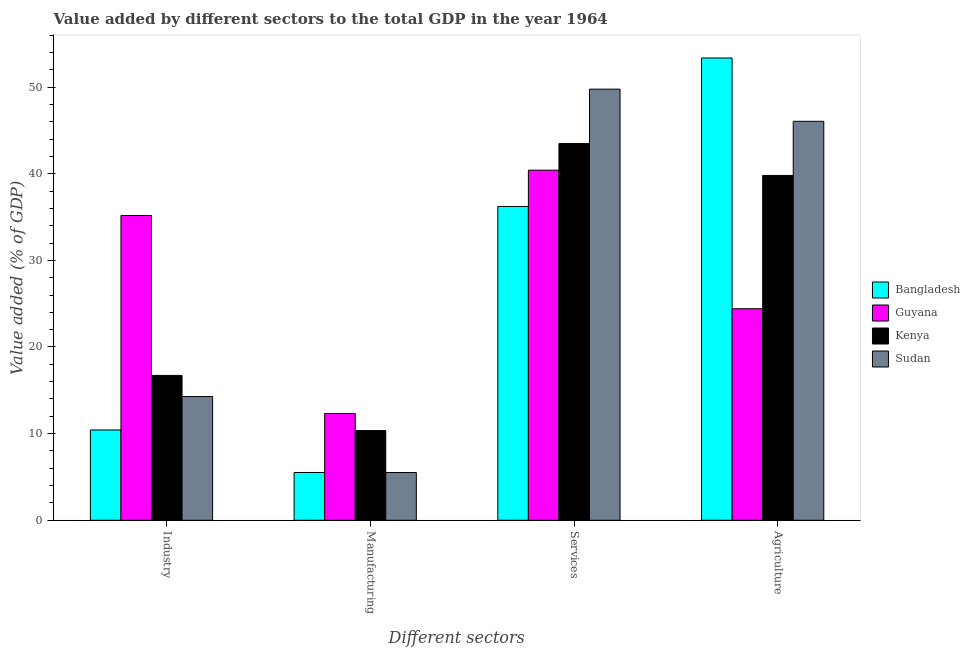How many different coloured bars are there?
Ensure brevity in your answer.  4. How many groups of bars are there?
Provide a short and direct response. 4. Are the number of bars per tick equal to the number of legend labels?
Keep it short and to the point. Yes. How many bars are there on the 4th tick from the left?
Provide a short and direct response. 4. What is the label of the 1st group of bars from the left?
Offer a very short reply. Industry. What is the value added by manufacturing sector in Sudan?
Ensure brevity in your answer.  5.51. Across all countries, what is the maximum value added by agricultural sector?
Your answer should be very brief. 53.36. Across all countries, what is the minimum value added by services sector?
Provide a succinct answer. 36.22. In which country was the value added by industrial sector maximum?
Offer a very short reply. Guyana. In which country was the value added by services sector minimum?
Your answer should be compact. Bangladesh. What is the total value added by manufacturing sector in the graph?
Offer a very short reply. 33.7. What is the difference between the value added by agricultural sector in Guyana and that in Sudan?
Provide a short and direct response. -21.63. What is the difference between the value added by manufacturing sector in Bangladesh and the value added by industrial sector in Guyana?
Offer a very short reply. -29.66. What is the average value added by services sector per country?
Your answer should be compact. 42.47. What is the difference between the value added by manufacturing sector and value added by services sector in Bangladesh?
Your answer should be very brief. -30.71. In how many countries, is the value added by industrial sector greater than 54 %?
Provide a short and direct response. 0. What is the ratio of the value added by industrial sector in Kenya to that in Bangladesh?
Make the answer very short. 1.6. Is the value added by services sector in Guyana less than that in Bangladesh?
Give a very brief answer. No. Is the difference between the value added by services sector in Sudan and Guyana greater than the difference between the value added by industrial sector in Sudan and Guyana?
Make the answer very short. Yes. What is the difference between the highest and the second highest value added by agricultural sector?
Provide a succinct answer. 7.31. What is the difference between the highest and the lowest value added by agricultural sector?
Offer a very short reply. 28.94. In how many countries, is the value added by manufacturing sector greater than the average value added by manufacturing sector taken over all countries?
Your answer should be compact. 2. Is it the case that in every country, the sum of the value added by industrial sector and value added by services sector is greater than the sum of value added by manufacturing sector and value added by agricultural sector?
Make the answer very short. No. What does the 3rd bar from the left in Services represents?
Keep it short and to the point. Kenya. What does the 2nd bar from the right in Manufacturing represents?
Your response must be concise. Kenya. Is it the case that in every country, the sum of the value added by industrial sector and value added by manufacturing sector is greater than the value added by services sector?
Offer a terse response. No. How many bars are there?
Provide a short and direct response. 16. Are all the bars in the graph horizontal?
Provide a short and direct response. No. How many countries are there in the graph?
Give a very brief answer. 4. What is the difference between two consecutive major ticks on the Y-axis?
Provide a short and direct response. 10. Are the values on the major ticks of Y-axis written in scientific E-notation?
Ensure brevity in your answer.  No. Does the graph contain any zero values?
Your answer should be very brief. No. Where does the legend appear in the graph?
Make the answer very short. Center right. How many legend labels are there?
Offer a very short reply. 4. What is the title of the graph?
Provide a short and direct response. Value added by different sectors to the total GDP in the year 1964. Does "Malta" appear as one of the legend labels in the graph?
Offer a very short reply. No. What is the label or title of the X-axis?
Offer a terse response. Different sectors. What is the label or title of the Y-axis?
Offer a terse response. Value added (% of GDP). What is the Value added (% of GDP) of Bangladesh in Industry?
Your answer should be very brief. 10.42. What is the Value added (% of GDP) of Guyana in Industry?
Provide a succinct answer. 35.18. What is the Value added (% of GDP) in Kenya in Industry?
Offer a terse response. 16.72. What is the Value added (% of GDP) in Sudan in Industry?
Your answer should be compact. 14.28. What is the Value added (% of GDP) in Bangladesh in Manufacturing?
Provide a short and direct response. 5.51. What is the Value added (% of GDP) in Guyana in Manufacturing?
Your answer should be compact. 12.33. What is the Value added (% of GDP) of Kenya in Manufacturing?
Your answer should be very brief. 10.35. What is the Value added (% of GDP) of Sudan in Manufacturing?
Your response must be concise. 5.51. What is the Value added (% of GDP) of Bangladesh in Services?
Ensure brevity in your answer.  36.22. What is the Value added (% of GDP) of Guyana in Services?
Provide a short and direct response. 40.41. What is the Value added (% of GDP) in Kenya in Services?
Make the answer very short. 43.48. What is the Value added (% of GDP) of Sudan in Services?
Provide a succinct answer. 49.76. What is the Value added (% of GDP) in Bangladesh in Agriculture?
Keep it short and to the point. 53.36. What is the Value added (% of GDP) in Guyana in Agriculture?
Give a very brief answer. 24.42. What is the Value added (% of GDP) in Kenya in Agriculture?
Your response must be concise. 39.8. What is the Value added (% of GDP) of Sudan in Agriculture?
Make the answer very short. 46.05. Across all Different sectors, what is the maximum Value added (% of GDP) in Bangladesh?
Provide a short and direct response. 53.36. Across all Different sectors, what is the maximum Value added (% of GDP) of Guyana?
Give a very brief answer. 40.41. Across all Different sectors, what is the maximum Value added (% of GDP) of Kenya?
Provide a short and direct response. 43.48. Across all Different sectors, what is the maximum Value added (% of GDP) in Sudan?
Ensure brevity in your answer.  49.76. Across all Different sectors, what is the minimum Value added (% of GDP) in Bangladesh?
Make the answer very short. 5.51. Across all Different sectors, what is the minimum Value added (% of GDP) of Guyana?
Your response must be concise. 12.33. Across all Different sectors, what is the minimum Value added (% of GDP) of Kenya?
Your answer should be very brief. 10.35. Across all Different sectors, what is the minimum Value added (% of GDP) in Sudan?
Give a very brief answer. 5.51. What is the total Value added (% of GDP) in Bangladesh in the graph?
Your answer should be very brief. 105.51. What is the total Value added (% of GDP) of Guyana in the graph?
Give a very brief answer. 112.33. What is the total Value added (% of GDP) in Kenya in the graph?
Provide a succinct answer. 110.35. What is the total Value added (% of GDP) in Sudan in the graph?
Make the answer very short. 115.6. What is the difference between the Value added (% of GDP) of Bangladesh in Industry and that in Manufacturing?
Ensure brevity in your answer.  4.91. What is the difference between the Value added (% of GDP) of Guyana in Industry and that in Manufacturing?
Provide a succinct answer. 22.85. What is the difference between the Value added (% of GDP) of Kenya in Industry and that in Manufacturing?
Provide a short and direct response. 6.37. What is the difference between the Value added (% of GDP) of Sudan in Industry and that in Manufacturing?
Provide a succinct answer. 8.77. What is the difference between the Value added (% of GDP) in Bangladesh in Industry and that in Services?
Provide a short and direct response. -25.8. What is the difference between the Value added (% of GDP) of Guyana in Industry and that in Services?
Provide a short and direct response. -5.23. What is the difference between the Value added (% of GDP) of Kenya in Industry and that in Services?
Offer a very short reply. -26.76. What is the difference between the Value added (% of GDP) of Sudan in Industry and that in Services?
Provide a succinct answer. -35.48. What is the difference between the Value added (% of GDP) in Bangladesh in Industry and that in Agriculture?
Keep it short and to the point. -42.93. What is the difference between the Value added (% of GDP) of Guyana in Industry and that in Agriculture?
Ensure brevity in your answer.  10.76. What is the difference between the Value added (% of GDP) of Kenya in Industry and that in Agriculture?
Provide a succinct answer. -23.08. What is the difference between the Value added (% of GDP) in Sudan in Industry and that in Agriculture?
Offer a very short reply. -31.77. What is the difference between the Value added (% of GDP) in Bangladesh in Manufacturing and that in Services?
Your answer should be very brief. -30.71. What is the difference between the Value added (% of GDP) in Guyana in Manufacturing and that in Services?
Offer a terse response. -28.08. What is the difference between the Value added (% of GDP) of Kenya in Manufacturing and that in Services?
Your response must be concise. -33.13. What is the difference between the Value added (% of GDP) of Sudan in Manufacturing and that in Services?
Your answer should be very brief. -44.25. What is the difference between the Value added (% of GDP) of Bangladesh in Manufacturing and that in Agriculture?
Offer a very short reply. -47.84. What is the difference between the Value added (% of GDP) in Guyana in Manufacturing and that in Agriculture?
Give a very brief answer. -12.09. What is the difference between the Value added (% of GDP) in Kenya in Manufacturing and that in Agriculture?
Your answer should be very brief. -29.45. What is the difference between the Value added (% of GDP) of Sudan in Manufacturing and that in Agriculture?
Give a very brief answer. -40.54. What is the difference between the Value added (% of GDP) of Bangladesh in Services and that in Agriculture?
Offer a very short reply. -17.14. What is the difference between the Value added (% of GDP) of Guyana in Services and that in Agriculture?
Your answer should be very brief. 15.99. What is the difference between the Value added (% of GDP) in Kenya in Services and that in Agriculture?
Make the answer very short. 3.68. What is the difference between the Value added (% of GDP) in Sudan in Services and that in Agriculture?
Provide a succinct answer. 3.71. What is the difference between the Value added (% of GDP) in Bangladesh in Industry and the Value added (% of GDP) in Guyana in Manufacturing?
Offer a terse response. -1.9. What is the difference between the Value added (% of GDP) in Bangladesh in Industry and the Value added (% of GDP) in Kenya in Manufacturing?
Your answer should be very brief. 0.07. What is the difference between the Value added (% of GDP) of Bangladesh in Industry and the Value added (% of GDP) of Sudan in Manufacturing?
Offer a terse response. 4.91. What is the difference between the Value added (% of GDP) of Guyana in Industry and the Value added (% of GDP) of Kenya in Manufacturing?
Ensure brevity in your answer.  24.83. What is the difference between the Value added (% of GDP) of Guyana in Industry and the Value added (% of GDP) of Sudan in Manufacturing?
Provide a succinct answer. 29.67. What is the difference between the Value added (% of GDP) in Kenya in Industry and the Value added (% of GDP) in Sudan in Manufacturing?
Offer a terse response. 11.21. What is the difference between the Value added (% of GDP) in Bangladesh in Industry and the Value added (% of GDP) in Guyana in Services?
Provide a succinct answer. -29.98. What is the difference between the Value added (% of GDP) in Bangladesh in Industry and the Value added (% of GDP) in Kenya in Services?
Provide a succinct answer. -33.06. What is the difference between the Value added (% of GDP) in Bangladesh in Industry and the Value added (% of GDP) in Sudan in Services?
Keep it short and to the point. -39.34. What is the difference between the Value added (% of GDP) in Guyana in Industry and the Value added (% of GDP) in Kenya in Services?
Keep it short and to the point. -8.3. What is the difference between the Value added (% of GDP) in Guyana in Industry and the Value added (% of GDP) in Sudan in Services?
Ensure brevity in your answer.  -14.58. What is the difference between the Value added (% of GDP) in Kenya in Industry and the Value added (% of GDP) in Sudan in Services?
Keep it short and to the point. -33.04. What is the difference between the Value added (% of GDP) in Bangladesh in Industry and the Value added (% of GDP) in Guyana in Agriculture?
Provide a succinct answer. -13.99. What is the difference between the Value added (% of GDP) of Bangladesh in Industry and the Value added (% of GDP) of Kenya in Agriculture?
Your response must be concise. -29.38. What is the difference between the Value added (% of GDP) of Bangladesh in Industry and the Value added (% of GDP) of Sudan in Agriculture?
Your answer should be very brief. -35.63. What is the difference between the Value added (% of GDP) of Guyana in Industry and the Value added (% of GDP) of Kenya in Agriculture?
Offer a very short reply. -4.62. What is the difference between the Value added (% of GDP) of Guyana in Industry and the Value added (% of GDP) of Sudan in Agriculture?
Your answer should be very brief. -10.87. What is the difference between the Value added (% of GDP) of Kenya in Industry and the Value added (% of GDP) of Sudan in Agriculture?
Offer a very short reply. -29.33. What is the difference between the Value added (% of GDP) of Bangladesh in Manufacturing and the Value added (% of GDP) of Guyana in Services?
Ensure brevity in your answer.  -34.89. What is the difference between the Value added (% of GDP) in Bangladesh in Manufacturing and the Value added (% of GDP) in Kenya in Services?
Offer a terse response. -37.97. What is the difference between the Value added (% of GDP) of Bangladesh in Manufacturing and the Value added (% of GDP) of Sudan in Services?
Your answer should be compact. -44.25. What is the difference between the Value added (% of GDP) of Guyana in Manufacturing and the Value added (% of GDP) of Kenya in Services?
Provide a short and direct response. -31.16. What is the difference between the Value added (% of GDP) in Guyana in Manufacturing and the Value added (% of GDP) in Sudan in Services?
Provide a short and direct response. -37.44. What is the difference between the Value added (% of GDP) in Kenya in Manufacturing and the Value added (% of GDP) in Sudan in Services?
Keep it short and to the point. -39.41. What is the difference between the Value added (% of GDP) of Bangladesh in Manufacturing and the Value added (% of GDP) of Guyana in Agriculture?
Your answer should be compact. -18.9. What is the difference between the Value added (% of GDP) of Bangladesh in Manufacturing and the Value added (% of GDP) of Kenya in Agriculture?
Your response must be concise. -34.29. What is the difference between the Value added (% of GDP) of Bangladesh in Manufacturing and the Value added (% of GDP) of Sudan in Agriculture?
Provide a succinct answer. -40.53. What is the difference between the Value added (% of GDP) in Guyana in Manufacturing and the Value added (% of GDP) in Kenya in Agriculture?
Your response must be concise. -27.48. What is the difference between the Value added (% of GDP) in Guyana in Manufacturing and the Value added (% of GDP) in Sudan in Agriculture?
Your answer should be compact. -33.72. What is the difference between the Value added (% of GDP) of Kenya in Manufacturing and the Value added (% of GDP) of Sudan in Agriculture?
Ensure brevity in your answer.  -35.7. What is the difference between the Value added (% of GDP) in Bangladesh in Services and the Value added (% of GDP) in Guyana in Agriculture?
Provide a short and direct response. 11.8. What is the difference between the Value added (% of GDP) of Bangladesh in Services and the Value added (% of GDP) of Kenya in Agriculture?
Provide a succinct answer. -3.58. What is the difference between the Value added (% of GDP) of Bangladesh in Services and the Value added (% of GDP) of Sudan in Agriculture?
Ensure brevity in your answer.  -9.83. What is the difference between the Value added (% of GDP) in Guyana in Services and the Value added (% of GDP) in Kenya in Agriculture?
Keep it short and to the point. 0.61. What is the difference between the Value added (% of GDP) of Guyana in Services and the Value added (% of GDP) of Sudan in Agriculture?
Your response must be concise. -5.64. What is the difference between the Value added (% of GDP) of Kenya in Services and the Value added (% of GDP) of Sudan in Agriculture?
Make the answer very short. -2.57. What is the average Value added (% of GDP) of Bangladesh per Different sectors?
Offer a very short reply. 26.38. What is the average Value added (% of GDP) of Guyana per Different sectors?
Offer a very short reply. 28.08. What is the average Value added (% of GDP) in Kenya per Different sectors?
Keep it short and to the point. 27.59. What is the average Value added (% of GDP) in Sudan per Different sectors?
Give a very brief answer. 28.9. What is the difference between the Value added (% of GDP) of Bangladesh and Value added (% of GDP) of Guyana in Industry?
Provide a succinct answer. -24.75. What is the difference between the Value added (% of GDP) in Bangladesh and Value added (% of GDP) in Kenya in Industry?
Give a very brief answer. -6.3. What is the difference between the Value added (% of GDP) in Bangladesh and Value added (% of GDP) in Sudan in Industry?
Offer a terse response. -3.86. What is the difference between the Value added (% of GDP) in Guyana and Value added (% of GDP) in Kenya in Industry?
Provide a succinct answer. 18.46. What is the difference between the Value added (% of GDP) in Guyana and Value added (% of GDP) in Sudan in Industry?
Provide a succinct answer. 20.9. What is the difference between the Value added (% of GDP) in Kenya and Value added (% of GDP) in Sudan in Industry?
Offer a terse response. 2.44. What is the difference between the Value added (% of GDP) of Bangladesh and Value added (% of GDP) of Guyana in Manufacturing?
Your answer should be compact. -6.81. What is the difference between the Value added (% of GDP) in Bangladesh and Value added (% of GDP) in Kenya in Manufacturing?
Provide a succinct answer. -4.84. What is the difference between the Value added (% of GDP) in Bangladesh and Value added (% of GDP) in Sudan in Manufacturing?
Your response must be concise. 0. What is the difference between the Value added (% of GDP) of Guyana and Value added (% of GDP) of Kenya in Manufacturing?
Provide a short and direct response. 1.97. What is the difference between the Value added (% of GDP) in Guyana and Value added (% of GDP) in Sudan in Manufacturing?
Your response must be concise. 6.81. What is the difference between the Value added (% of GDP) in Kenya and Value added (% of GDP) in Sudan in Manufacturing?
Provide a short and direct response. 4.84. What is the difference between the Value added (% of GDP) of Bangladesh and Value added (% of GDP) of Guyana in Services?
Your response must be concise. -4.19. What is the difference between the Value added (% of GDP) of Bangladesh and Value added (% of GDP) of Kenya in Services?
Give a very brief answer. -7.26. What is the difference between the Value added (% of GDP) in Bangladesh and Value added (% of GDP) in Sudan in Services?
Make the answer very short. -13.54. What is the difference between the Value added (% of GDP) in Guyana and Value added (% of GDP) in Kenya in Services?
Your answer should be compact. -3.07. What is the difference between the Value added (% of GDP) of Guyana and Value added (% of GDP) of Sudan in Services?
Your answer should be compact. -9.35. What is the difference between the Value added (% of GDP) in Kenya and Value added (% of GDP) in Sudan in Services?
Your answer should be compact. -6.28. What is the difference between the Value added (% of GDP) of Bangladesh and Value added (% of GDP) of Guyana in Agriculture?
Provide a short and direct response. 28.94. What is the difference between the Value added (% of GDP) of Bangladesh and Value added (% of GDP) of Kenya in Agriculture?
Give a very brief answer. 13.56. What is the difference between the Value added (% of GDP) of Bangladesh and Value added (% of GDP) of Sudan in Agriculture?
Your answer should be very brief. 7.31. What is the difference between the Value added (% of GDP) of Guyana and Value added (% of GDP) of Kenya in Agriculture?
Your answer should be compact. -15.38. What is the difference between the Value added (% of GDP) of Guyana and Value added (% of GDP) of Sudan in Agriculture?
Provide a short and direct response. -21.63. What is the difference between the Value added (% of GDP) in Kenya and Value added (% of GDP) in Sudan in Agriculture?
Provide a succinct answer. -6.25. What is the ratio of the Value added (% of GDP) of Bangladesh in Industry to that in Manufacturing?
Offer a terse response. 1.89. What is the ratio of the Value added (% of GDP) of Guyana in Industry to that in Manufacturing?
Offer a terse response. 2.85. What is the ratio of the Value added (% of GDP) in Kenya in Industry to that in Manufacturing?
Your response must be concise. 1.62. What is the ratio of the Value added (% of GDP) in Sudan in Industry to that in Manufacturing?
Make the answer very short. 2.59. What is the ratio of the Value added (% of GDP) of Bangladesh in Industry to that in Services?
Offer a very short reply. 0.29. What is the ratio of the Value added (% of GDP) of Guyana in Industry to that in Services?
Provide a succinct answer. 0.87. What is the ratio of the Value added (% of GDP) in Kenya in Industry to that in Services?
Your answer should be very brief. 0.38. What is the ratio of the Value added (% of GDP) in Sudan in Industry to that in Services?
Ensure brevity in your answer.  0.29. What is the ratio of the Value added (% of GDP) in Bangladesh in Industry to that in Agriculture?
Offer a very short reply. 0.2. What is the ratio of the Value added (% of GDP) in Guyana in Industry to that in Agriculture?
Ensure brevity in your answer.  1.44. What is the ratio of the Value added (% of GDP) in Kenya in Industry to that in Agriculture?
Your answer should be very brief. 0.42. What is the ratio of the Value added (% of GDP) in Sudan in Industry to that in Agriculture?
Keep it short and to the point. 0.31. What is the ratio of the Value added (% of GDP) in Bangladesh in Manufacturing to that in Services?
Ensure brevity in your answer.  0.15. What is the ratio of the Value added (% of GDP) in Guyana in Manufacturing to that in Services?
Give a very brief answer. 0.3. What is the ratio of the Value added (% of GDP) of Kenya in Manufacturing to that in Services?
Your answer should be compact. 0.24. What is the ratio of the Value added (% of GDP) of Sudan in Manufacturing to that in Services?
Provide a short and direct response. 0.11. What is the ratio of the Value added (% of GDP) of Bangladesh in Manufacturing to that in Agriculture?
Your answer should be compact. 0.1. What is the ratio of the Value added (% of GDP) of Guyana in Manufacturing to that in Agriculture?
Make the answer very short. 0.5. What is the ratio of the Value added (% of GDP) of Kenya in Manufacturing to that in Agriculture?
Offer a very short reply. 0.26. What is the ratio of the Value added (% of GDP) of Sudan in Manufacturing to that in Agriculture?
Provide a succinct answer. 0.12. What is the ratio of the Value added (% of GDP) in Bangladesh in Services to that in Agriculture?
Provide a short and direct response. 0.68. What is the ratio of the Value added (% of GDP) of Guyana in Services to that in Agriculture?
Keep it short and to the point. 1.65. What is the ratio of the Value added (% of GDP) of Kenya in Services to that in Agriculture?
Make the answer very short. 1.09. What is the ratio of the Value added (% of GDP) in Sudan in Services to that in Agriculture?
Offer a terse response. 1.08. What is the difference between the highest and the second highest Value added (% of GDP) of Bangladesh?
Your answer should be compact. 17.14. What is the difference between the highest and the second highest Value added (% of GDP) of Guyana?
Keep it short and to the point. 5.23. What is the difference between the highest and the second highest Value added (% of GDP) of Kenya?
Ensure brevity in your answer.  3.68. What is the difference between the highest and the second highest Value added (% of GDP) of Sudan?
Your answer should be compact. 3.71. What is the difference between the highest and the lowest Value added (% of GDP) of Bangladesh?
Keep it short and to the point. 47.84. What is the difference between the highest and the lowest Value added (% of GDP) in Guyana?
Your response must be concise. 28.08. What is the difference between the highest and the lowest Value added (% of GDP) in Kenya?
Keep it short and to the point. 33.13. What is the difference between the highest and the lowest Value added (% of GDP) in Sudan?
Make the answer very short. 44.25. 